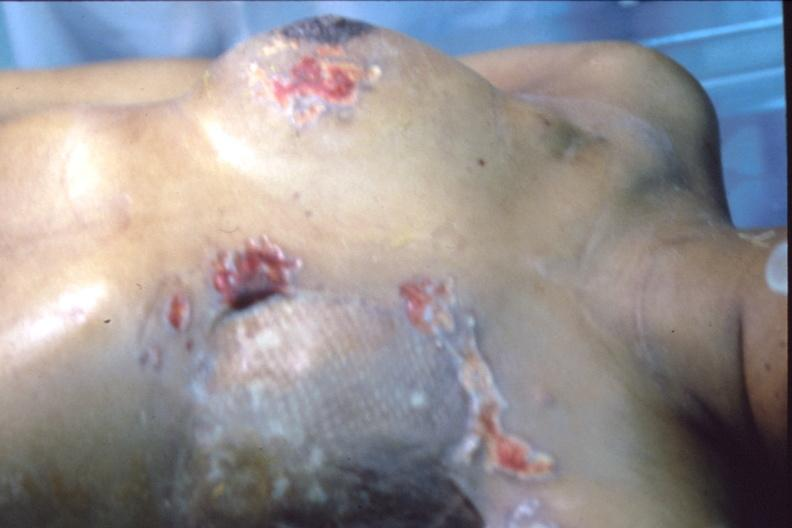what does this image show?
Answer the question using a single word or phrase. Mastectomy scars with skin metastases 